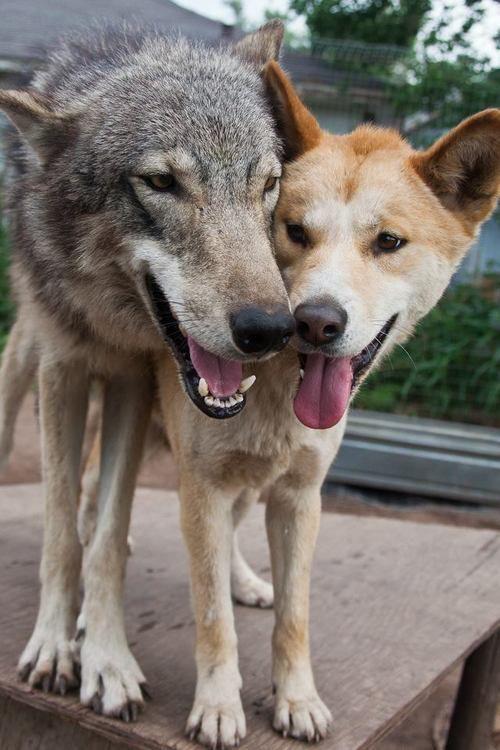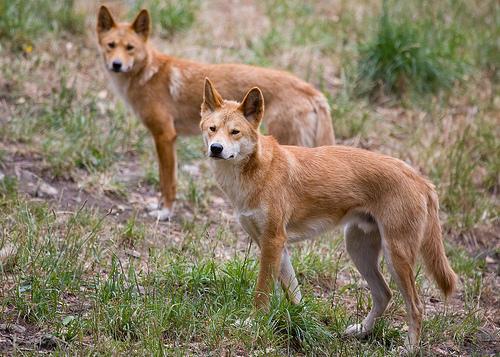The first image is the image on the left, the second image is the image on the right. Given the left and right images, does the statement "There are exactly two animals in the image on the right." hold true? Answer yes or no. Yes. 